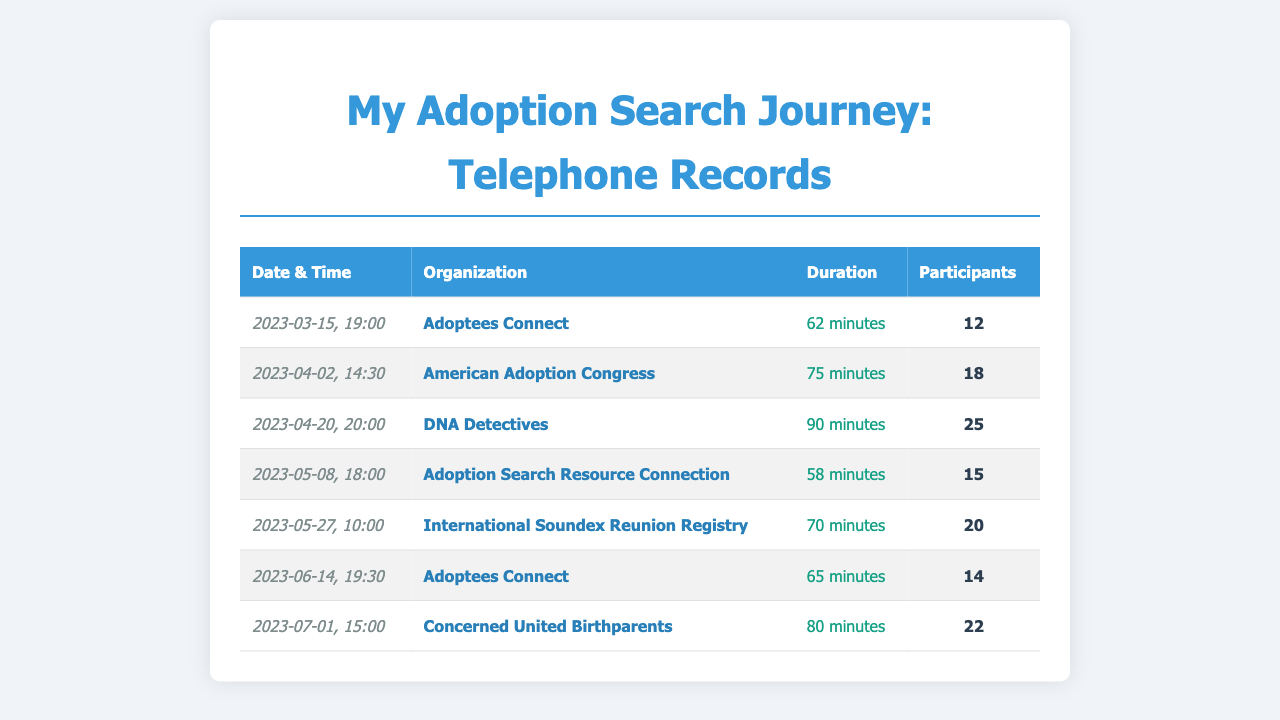What is the duration of the call on April 20, 2023? The duration of the call is specified in the document as 90 minutes on that date.
Answer: 90 minutes Who organized the call on May 27, 2023? The name of the organization that hosted the call is listed in the document under the corresponding date.
Answer: International Soundex Reunion Registry How many participants joined the call on March 15, 2023? The number of participants is indicated in the record for that specific call.
Answer: 12 Which organization had the most participants on a single call? To find this, we need to compare the participant numbers across all calls, and the document indicates that the call with the highest number is listed.
Answer: DNA Detectives What was the date of the call with the shortest duration? The lengths of the calls can be evaluated to find the shortest one, which requires looking at the durations listed.
Answer: 2023-05-08 How long was the call held by Adoptees Connect in June 2023? The specific duration for the call on that date is provided in the document.
Answer: 65 minutes What is the total number of participants across all calls combined? The total can be calculated by adding the participant numbers in each row of the document.
Answer: 171 Which call had a duration of 75 minutes? The document specifies which call lasted 75 minutes based on the date and organization listed.
Answer: American Adoption Congress 